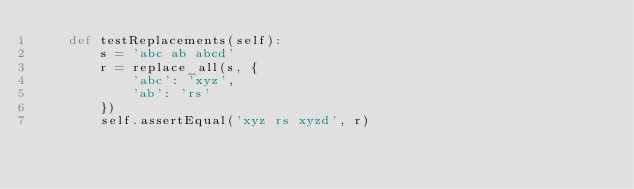Convert code to text. <code><loc_0><loc_0><loc_500><loc_500><_Python_>    def testReplacements(self):
        s = 'abc ab abcd'
        r = replace_all(s, {
            'abc': 'xyz',
            'ab': 'rs'
        })
        self.assertEqual('xyz rs xyzd', r)
</code> 